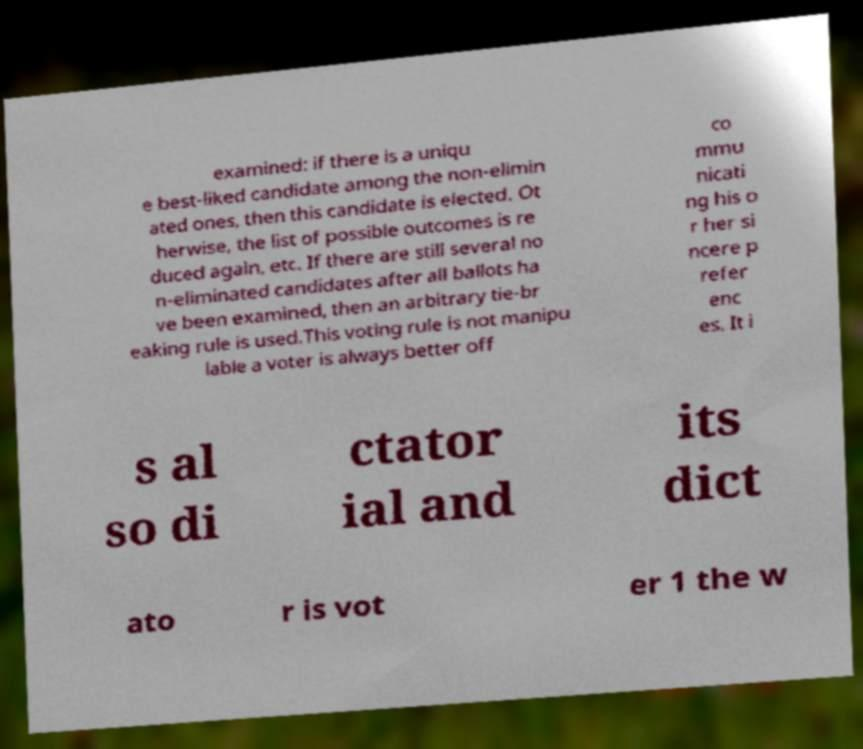Could you assist in decoding the text presented in this image and type it out clearly? examined: if there is a uniqu e best-liked candidate among the non-elimin ated ones, then this candidate is elected. Ot herwise, the list of possible outcomes is re duced again, etc. If there are still several no n-eliminated candidates after all ballots ha ve been examined, then an arbitrary tie-br eaking rule is used.This voting rule is not manipu lable a voter is always better off co mmu nicati ng his o r her si ncere p refer enc es. It i s al so di ctator ial and its dict ato r is vot er 1 the w 